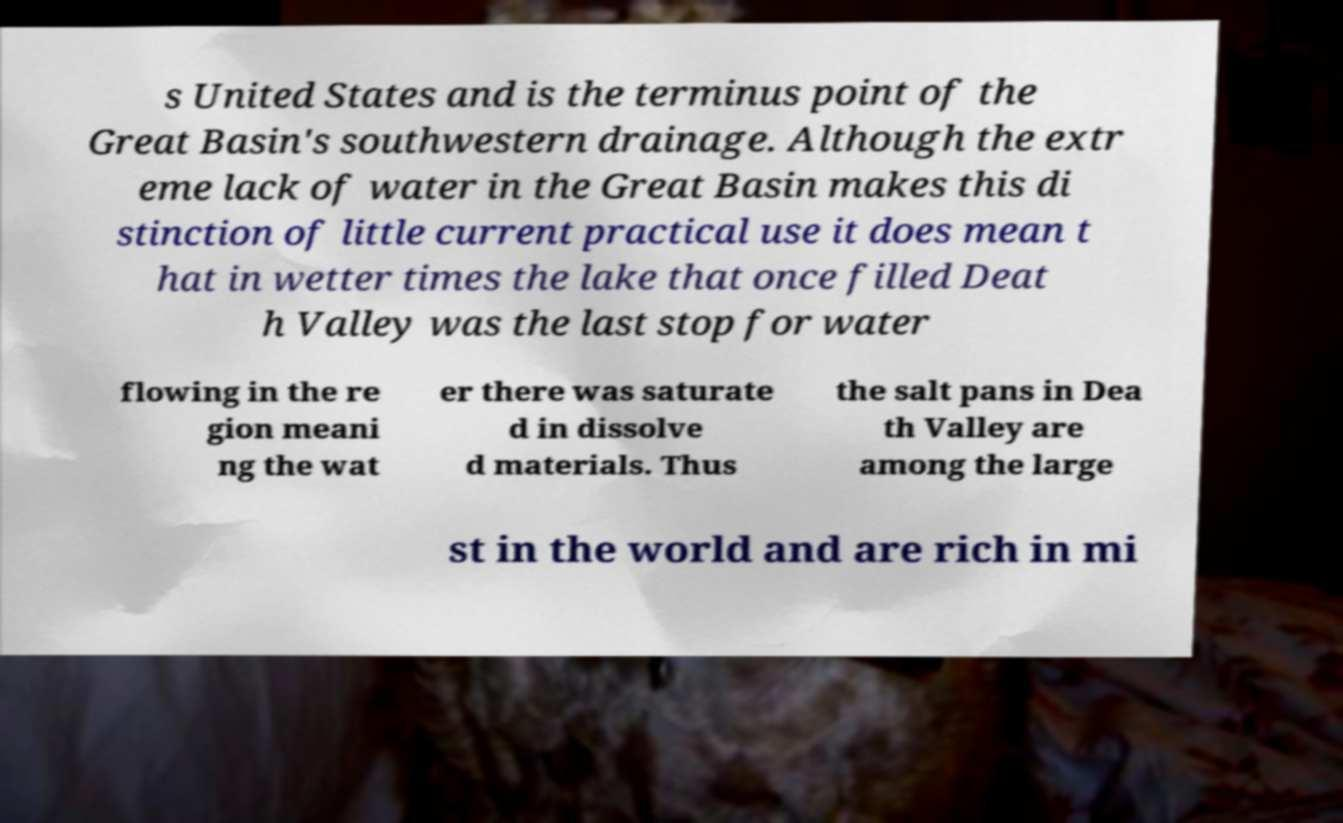Could you extract and type out the text from this image? s United States and is the terminus point of the Great Basin's southwestern drainage. Although the extr eme lack of water in the Great Basin makes this di stinction of little current practical use it does mean t hat in wetter times the lake that once filled Deat h Valley was the last stop for water flowing in the re gion meani ng the wat er there was saturate d in dissolve d materials. Thus the salt pans in Dea th Valley are among the large st in the world and are rich in mi 